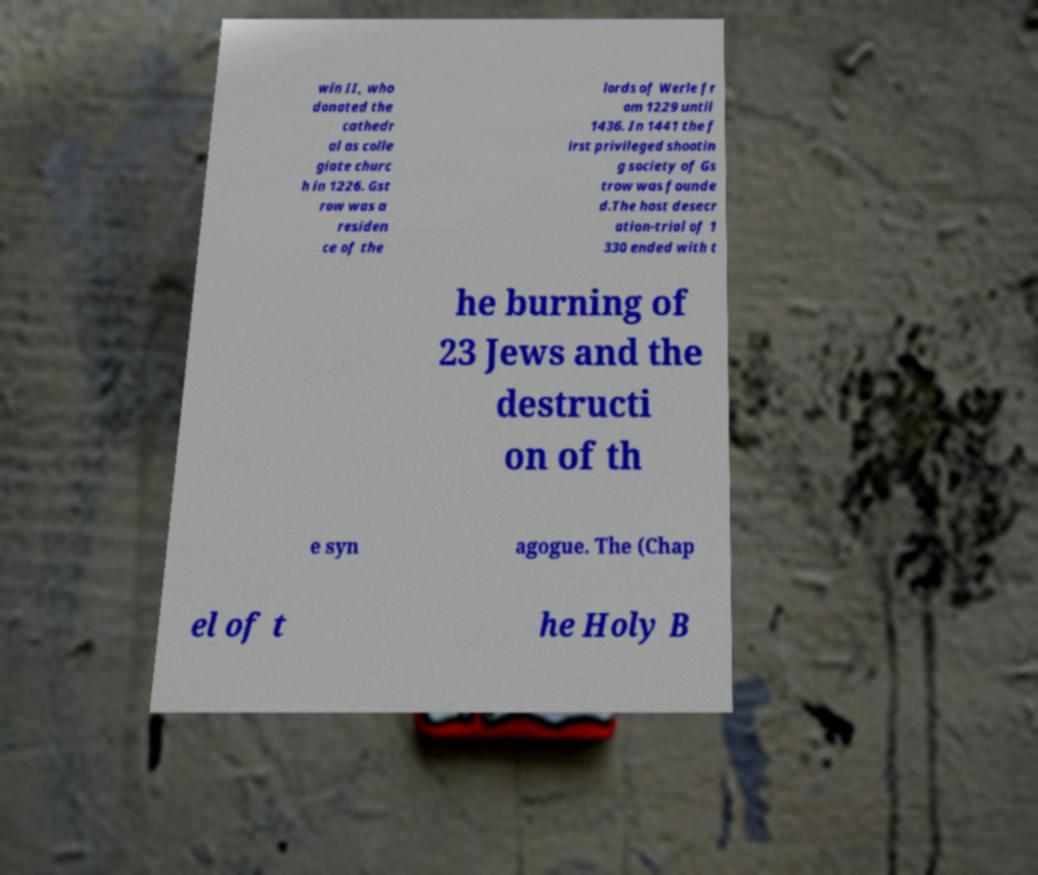Could you extract and type out the text from this image? win II, who donated the cathedr al as colle giate churc h in 1226. Gst row was a residen ce of the lords of Werle fr om 1229 until 1436. In 1441 the f irst privileged shootin g society of Gs trow was founde d.The host desecr ation-trial of 1 330 ended with t he burning of 23 Jews and the destructi on of th e syn agogue. The (Chap el of t he Holy B 